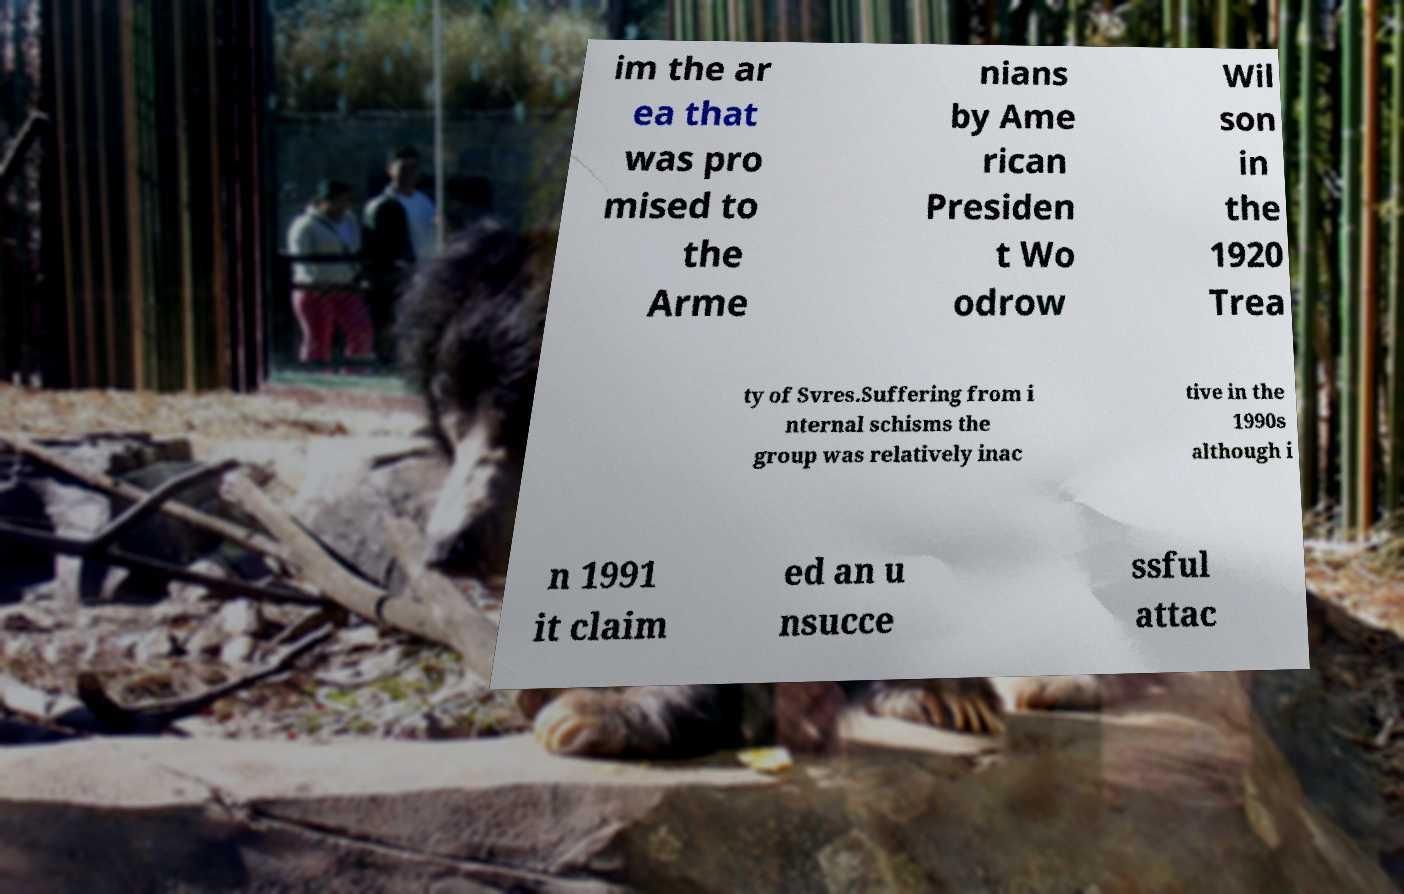What messages or text are displayed in this image? I need them in a readable, typed format. im the ar ea that was pro mised to the Arme nians by Ame rican Presiden t Wo odrow Wil son in the 1920 Trea ty of Svres.Suffering from i nternal schisms the group was relatively inac tive in the 1990s although i n 1991 it claim ed an u nsucce ssful attac 